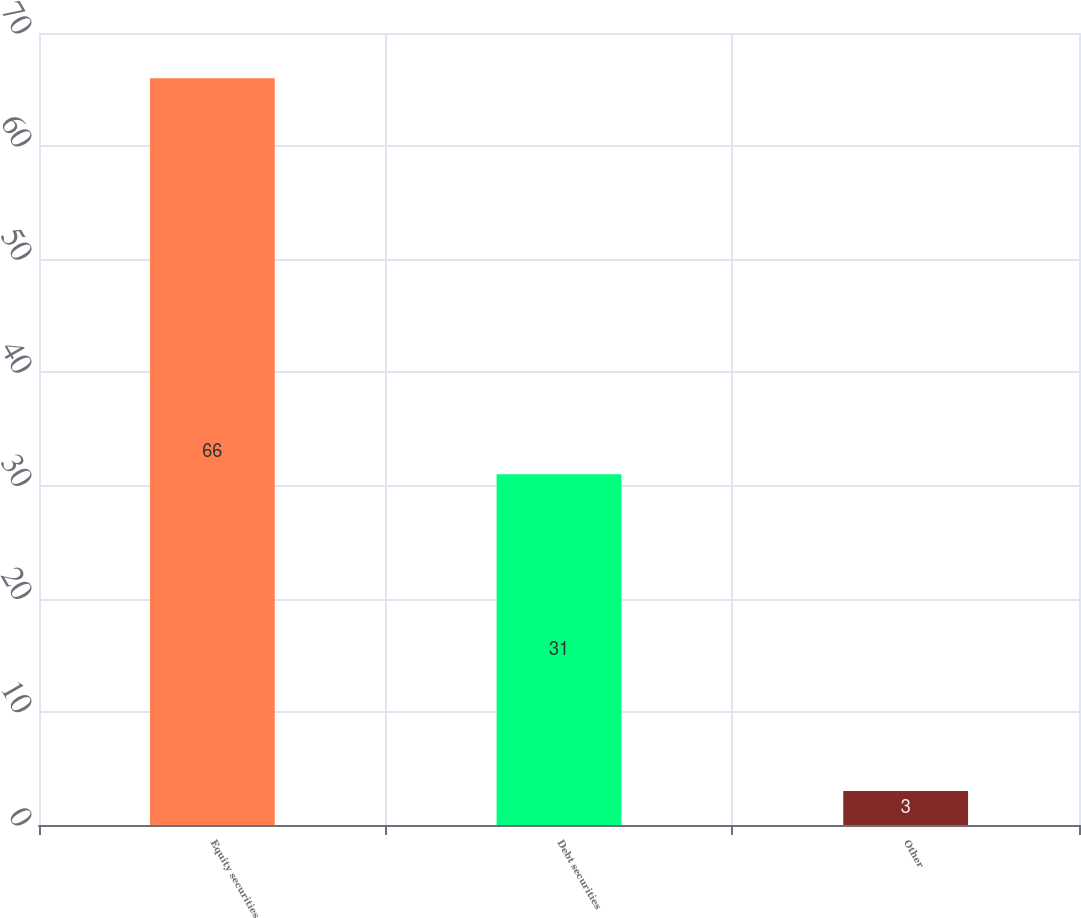<chart> <loc_0><loc_0><loc_500><loc_500><bar_chart><fcel>Equity securities<fcel>Debt securities<fcel>Other<nl><fcel>66<fcel>31<fcel>3<nl></chart> 